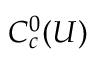Convert formula to latex. <formula><loc_0><loc_0><loc_500><loc_500>C _ { c } ^ { 0 } ( U )</formula> 